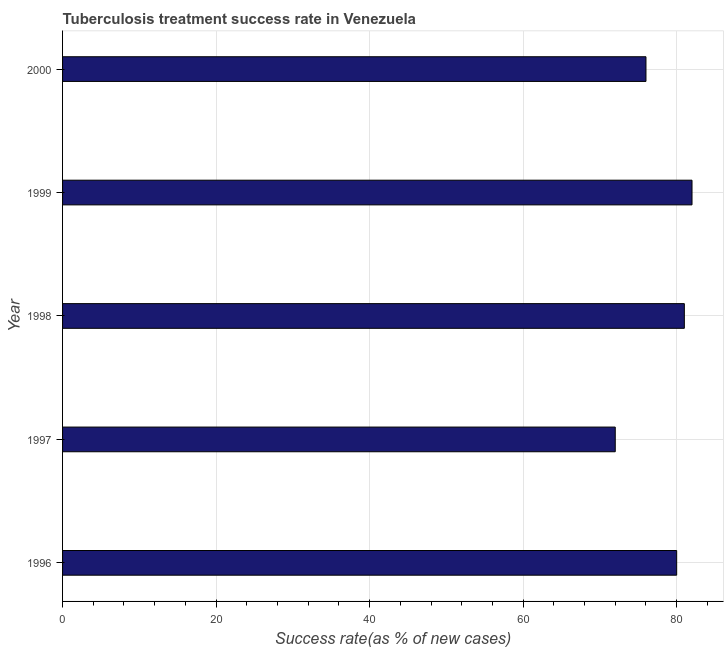Does the graph contain any zero values?
Your answer should be compact. No. Does the graph contain grids?
Offer a very short reply. Yes. What is the title of the graph?
Your answer should be compact. Tuberculosis treatment success rate in Venezuela. What is the label or title of the X-axis?
Give a very brief answer. Success rate(as % of new cases). What is the label or title of the Y-axis?
Offer a very short reply. Year. In which year was the tuberculosis treatment success rate maximum?
Your response must be concise. 1999. What is the sum of the tuberculosis treatment success rate?
Provide a short and direct response. 391. In how many years, is the tuberculosis treatment success rate greater than 60 %?
Ensure brevity in your answer.  5. Do a majority of the years between 1998 and 2000 (inclusive) have tuberculosis treatment success rate greater than 48 %?
Make the answer very short. Yes. What is the ratio of the tuberculosis treatment success rate in 1998 to that in 2000?
Your answer should be compact. 1.07. Is the tuberculosis treatment success rate in 1998 less than that in 1999?
Keep it short and to the point. Yes. What is the difference between the highest and the second highest tuberculosis treatment success rate?
Ensure brevity in your answer.  1. Is the sum of the tuberculosis treatment success rate in 1997 and 2000 greater than the maximum tuberculosis treatment success rate across all years?
Offer a very short reply. Yes. How many bars are there?
Provide a short and direct response. 5. Are all the bars in the graph horizontal?
Make the answer very short. Yes. How many years are there in the graph?
Offer a very short reply. 5. What is the difference between two consecutive major ticks on the X-axis?
Your answer should be compact. 20. What is the Success rate(as % of new cases) of 1997?
Provide a succinct answer. 72. What is the Success rate(as % of new cases) in 1998?
Keep it short and to the point. 81. What is the Success rate(as % of new cases) of 2000?
Provide a succinct answer. 76. What is the difference between the Success rate(as % of new cases) in 1997 and 1998?
Keep it short and to the point. -9. What is the difference between the Success rate(as % of new cases) in 1998 and 1999?
Provide a short and direct response. -1. What is the difference between the Success rate(as % of new cases) in 1998 and 2000?
Give a very brief answer. 5. What is the ratio of the Success rate(as % of new cases) in 1996 to that in 1997?
Provide a succinct answer. 1.11. What is the ratio of the Success rate(as % of new cases) in 1996 to that in 1998?
Your answer should be compact. 0.99. What is the ratio of the Success rate(as % of new cases) in 1996 to that in 1999?
Ensure brevity in your answer.  0.98. What is the ratio of the Success rate(as % of new cases) in 1996 to that in 2000?
Offer a terse response. 1.05. What is the ratio of the Success rate(as % of new cases) in 1997 to that in 1998?
Your answer should be compact. 0.89. What is the ratio of the Success rate(as % of new cases) in 1997 to that in 1999?
Your answer should be very brief. 0.88. What is the ratio of the Success rate(as % of new cases) in 1997 to that in 2000?
Make the answer very short. 0.95. What is the ratio of the Success rate(as % of new cases) in 1998 to that in 1999?
Make the answer very short. 0.99. What is the ratio of the Success rate(as % of new cases) in 1998 to that in 2000?
Ensure brevity in your answer.  1.07. What is the ratio of the Success rate(as % of new cases) in 1999 to that in 2000?
Offer a very short reply. 1.08. 